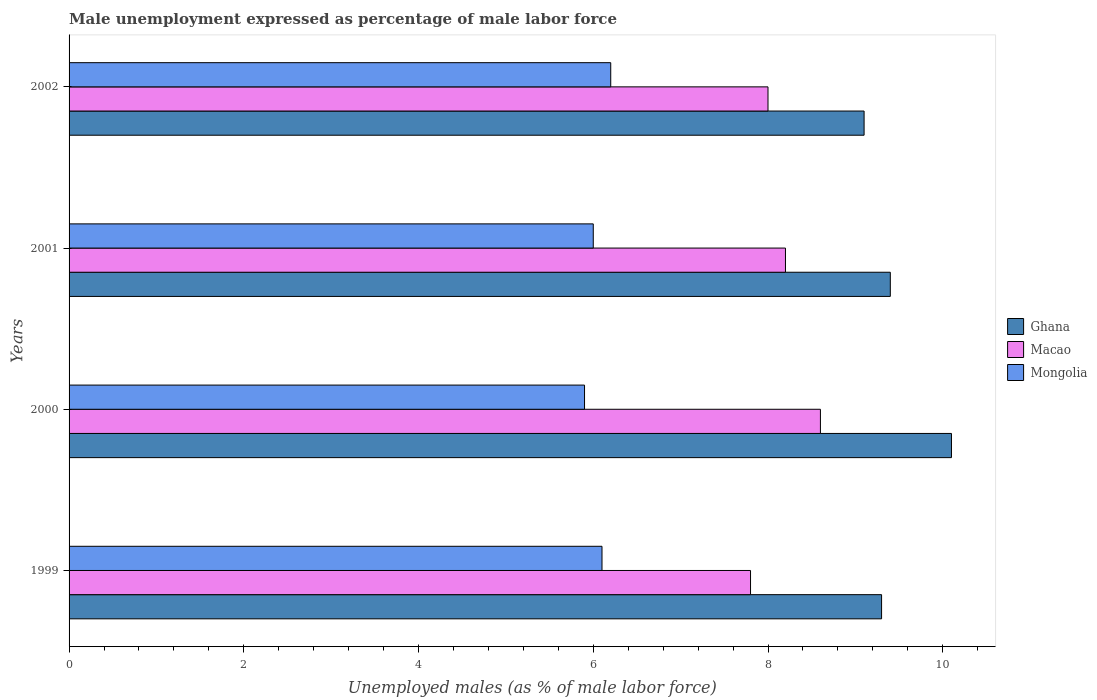Are the number of bars per tick equal to the number of legend labels?
Offer a very short reply. Yes. Are the number of bars on each tick of the Y-axis equal?
Keep it short and to the point. Yes. In how many cases, is the number of bars for a given year not equal to the number of legend labels?
Keep it short and to the point. 0. What is the unemployment in males in in Mongolia in 2000?
Provide a succinct answer. 5.9. Across all years, what is the maximum unemployment in males in in Ghana?
Your response must be concise. 10.1. Across all years, what is the minimum unemployment in males in in Mongolia?
Ensure brevity in your answer.  5.9. In which year was the unemployment in males in in Mongolia minimum?
Provide a succinct answer. 2000. What is the total unemployment in males in in Ghana in the graph?
Give a very brief answer. 37.9. What is the difference between the unemployment in males in in Macao in 2001 and that in 2002?
Make the answer very short. 0.2. What is the difference between the unemployment in males in in Macao in 2001 and the unemployment in males in in Mongolia in 1999?
Make the answer very short. 2.1. What is the average unemployment in males in in Mongolia per year?
Provide a short and direct response. 6.05. In the year 1999, what is the difference between the unemployment in males in in Ghana and unemployment in males in in Mongolia?
Your answer should be very brief. 3.2. In how many years, is the unemployment in males in in Ghana greater than 6.4 %?
Ensure brevity in your answer.  4. What is the ratio of the unemployment in males in in Ghana in 2000 to that in 2002?
Keep it short and to the point. 1.11. Is the unemployment in males in in Ghana in 2000 less than that in 2001?
Offer a very short reply. No. What is the difference between the highest and the second highest unemployment in males in in Mongolia?
Your answer should be very brief. 0.1. What is the difference between the highest and the lowest unemployment in males in in Ghana?
Your answer should be compact. 1. In how many years, is the unemployment in males in in Ghana greater than the average unemployment in males in in Ghana taken over all years?
Your response must be concise. 1. What does the 1st bar from the top in 1999 represents?
Make the answer very short. Mongolia. What does the 2nd bar from the bottom in 2002 represents?
Offer a very short reply. Macao. Is it the case that in every year, the sum of the unemployment in males in in Macao and unemployment in males in in Mongolia is greater than the unemployment in males in in Ghana?
Offer a terse response. Yes. How many bars are there?
Offer a terse response. 12. How many years are there in the graph?
Offer a terse response. 4. Are the values on the major ticks of X-axis written in scientific E-notation?
Ensure brevity in your answer.  No. How are the legend labels stacked?
Provide a succinct answer. Vertical. What is the title of the graph?
Provide a succinct answer. Male unemployment expressed as percentage of male labor force. What is the label or title of the X-axis?
Offer a very short reply. Unemployed males (as % of male labor force). What is the label or title of the Y-axis?
Give a very brief answer. Years. What is the Unemployed males (as % of male labor force) in Ghana in 1999?
Your answer should be very brief. 9.3. What is the Unemployed males (as % of male labor force) of Macao in 1999?
Give a very brief answer. 7.8. What is the Unemployed males (as % of male labor force) in Mongolia in 1999?
Keep it short and to the point. 6.1. What is the Unemployed males (as % of male labor force) of Ghana in 2000?
Provide a succinct answer. 10.1. What is the Unemployed males (as % of male labor force) in Macao in 2000?
Offer a terse response. 8.6. What is the Unemployed males (as % of male labor force) of Mongolia in 2000?
Your response must be concise. 5.9. What is the Unemployed males (as % of male labor force) in Ghana in 2001?
Give a very brief answer. 9.4. What is the Unemployed males (as % of male labor force) in Macao in 2001?
Make the answer very short. 8.2. What is the Unemployed males (as % of male labor force) of Ghana in 2002?
Provide a succinct answer. 9.1. What is the Unemployed males (as % of male labor force) of Macao in 2002?
Your answer should be very brief. 8. What is the Unemployed males (as % of male labor force) of Mongolia in 2002?
Your answer should be very brief. 6.2. Across all years, what is the maximum Unemployed males (as % of male labor force) in Ghana?
Offer a terse response. 10.1. Across all years, what is the maximum Unemployed males (as % of male labor force) of Macao?
Keep it short and to the point. 8.6. Across all years, what is the maximum Unemployed males (as % of male labor force) in Mongolia?
Give a very brief answer. 6.2. Across all years, what is the minimum Unemployed males (as % of male labor force) of Ghana?
Your answer should be very brief. 9.1. Across all years, what is the minimum Unemployed males (as % of male labor force) in Macao?
Provide a short and direct response. 7.8. Across all years, what is the minimum Unemployed males (as % of male labor force) in Mongolia?
Provide a succinct answer. 5.9. What is the total Unemployed males (as % of male labor force) of Ghana in the graph?
Provide a succinct answer. 37.9. What is the total Unemployed males (as % of male labor force) of Macao in the graph?
Offer a terse response. 32.6. What is the total Unemployed males (as % of male labor force) in Mongolia in the graph?
Offer a very short reply. 24.2. What is the difference between the Unemployed males (as % of male labor force) of Mongolia in 1999 and that in 2000?
Your answer should be very brief. 0.2. What is the difference between the Unemployed males (as % of male labor force) in Ghana in 1999 and that in 2001?
Provide a succinct answer. -0.1. What is the difference between the Unemployed males (as % of male labor force) of Mongolia in 1999 and that in 2001?
Offer a terse response. 0.1. What is the difference between the Unemployed males (as % of male labor force) in Ghana in 1999 and that in 2002?
Your response must be concise. 0.2. What is the difference between the Unemployed males (as % of male labor force) of Mongolia in 1999 and that in 2002?
Give a very brief answer. -0.1. What is the difference between the Unemployed males (as % of male labor force) of Macao in 2000 and that in 2001?
Your answer should be compact. 0.4. What is the difference between the Unemployed males (as % of male labor force) of Mongolia in 2000 and that in 2002?
Offer a terse response. -0.3. What is the difference between the Unemployed males (as % of male labor force) of Macao in 1999 and the Unemployed males (as % of male labor force) of Mongolia in 2000?
Offer a very short reply. 1.9. What is the difference between the Unemployed males (as % of male labor force) in Macao in 1999 and the Unemployed males (as % of male labor force) in Mongolia in 2001?
Give a very brief answer. 1.8. What is the difference between the Unemployed males (as % of male labor force) of Ghana in 1999 and the Unemployed males (as % of male labor force) of Macao in 2002?
Ensure brevity in your answer.  1.3. What is the difference between the Unemployed males (as % of male labor force) in Macao in 2000 and the Unemployed males (as % of male labor force) in Mongolia in 2001?
Make the answer very short. 2.6. What is the difference between the Unemployed males (as % of male labor force) in Ghana in 2000 and the Unemployed males (as % of male labor force) in Macao in 2002?
Ensure brevity in your answer.  2.1. What is the difference between the Unemployed males (as % of male labor force) in Ghana in 2001 and the Unemployed males (as % of male labor force) in Macao in 2002?
Your response must be concise. 1.4. What is the average Unemployed males (as % of male labor force) of Ghana per year?
Provide a succinct answer. 9.47. What is the average Unemployed males (as % of male labor force) in Macao per year?
Your response must be concise. 8.15. What is the average Unemployed males (as % of male labor force) in Mongolia per year?
Offer a terse response. 6.05. In the year 1999, what is the difference between the Unemployed males (as % of male labor force) in Ghana and Unemployed males (as % of male labor force) in Macao?
Provide a short and direct response. 1.5. In the year 1999, what is the difference between the Unemployed males (as % of male labor force) of Ghana and Unemployed males (as % of male labor force) of Mongolia?
Make the answer very short. 3.2. In the year 2000, what is the difference between the Unemployed males (as % of male labor force) of Ghana and Unemployed males (as % of male labor force) of Mongolia?
Provide a short and direct response. 4.2. In the year 2001, what is the difference between the Unemployed males (as % of male labor force) of Ghana and Unemployed males (as % of male labor force) of Macao?
Offer a very short reply. 1.2. In the year 2001, what is the difference between the Unemployed males (as % of male labor force) of Ghana and Unemployed males (as % of male labor force) of Mongolia?
Offer a terse response. 3.4. In the year 2001, what is the difference between the Unemployed males (as % of male labor force) of Macao and Unemployed males (as % of male labor force) of Mongolia?
Provide a succinct answer. 2.2. In the year 2002, what is the difference between the Unemployed males (as % of male labor force) in Ghana and Unemployed males (as % of male labor force) in Macao?
Provide a succinct answer. 1.1. In the year 2002, what is the difference between the Unemployed males (as % of male labor force) in Macao and Unemployed males (as % of male labor force) in Mongolia?
Your answer should be compact. 1.8. What is the ratio of the Unemployed males (as % of male labor force) of Ghana in 1999 to that in 2000?
Offer a terse response. 0.92. What is the ratio of the Unemployed males (as % of male labor force) of Macao in 1999 to that in 2000?
Your answer should be very brief. 0.91. What is the ratio of the Unemployed males (as % of male labor force) of Mongolia in 1999 to that in 2000?
Ensure brevity in your answer.  1.03. What is the ratio of the Unemployed males (as % of male labor force) of Macao in 1999 to that in 2001?
Keep it short and to the point. 0.95. What is the ratio of the Unemployed males (as % of male labor force) in Mongolia in 1999 to that in 2001?
Ensure brevity in your answer.  1.02. What is the ratio of the Unemployed males (as % of male labor force) in Ghana in 1999 to that in 2002?
Provide a short and direct response. 1.02. What is the ratio of the Unemployed males (as % of male labor force) in Macao in 1999 to that in 2002?
Your response must be concise. 0.97. What is the ratio of the Unemployed males (as % of male labor force) in Mongolia in 1999 to that in 2002?
Ensure brevity in your answer.  0.98. What is the ratio of the Unemployed males (as % of male labor force) in Ghana in 2000 to that in 2001?
Offer a very short reply. 1.07. What is the ratio of the Unemployed males (as % of male labor force) of Macao in 2000 to that in 2001?
Make the answer very short. 1.05. What is the ratio of the Unemployed males (as % of male labor force) of Mongolia in 2000 to that in 2001?
Provide a short and direct response. 0.98. What is the ratio of the Unemployed males (as % of male labor force) of Ghana in 2000 to that in 2002?
Your response must be concise. 1.11. What is the ratio of the Unemployed males (as % of male labor force) in Macao in 2000 to that in 2002?
Your answer should be very brief. 1.07. What is the ratio of the Unemployed males (as % of male labor force) in Mongolia in 2000 to that in 2002?
Your response must be concise. 0.95. What is the ratio of the Unemployed males (as % of male labor force) in Ghana in 2001 to that in 2002?
Provide a succinct answer. 1.03. What is the ratio of the Unemployed males (as % of male labor force) in Macao in 2001 to that in 2002?
Offer a terse response. 1.02. What is the difference between the highest and the second highest Unemployed males (as % of male labor force) in Ghana?
Offer a terse response. 0.7. What is the difference between the highest and the second highest Unemployed males (as % of male labor force) in Macao?
Your answer should be very brief. 0.4. What is the difference between the highest and the lowest Unemployed males (as % of male labor force) in Ghana?
Offer a terse response. 1. 